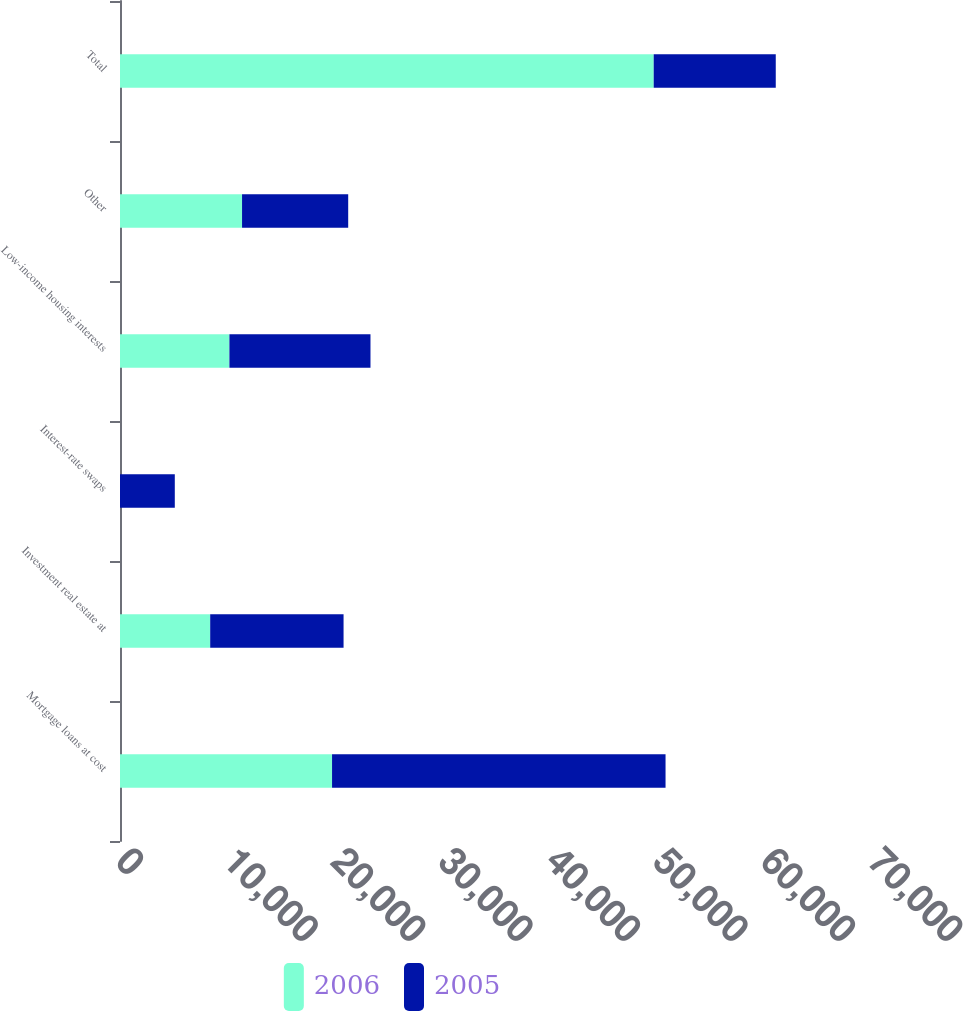Convert chart. <chart><loc_0><loc_0><loc_500><loc_500><stacked_bar_chart><ecel><fcel>Mortgage loans at cost<fcel>Investment real estate at<fcel>Interest-rate swaps<fcel>Low-income housing interests<fcel>Other<fcel>Total<nl><fcel>2006<fcel>19739<fcel>8396<fcel>0<fcel>10185<fcel>11361<fcel>49681<nl><fcel>2005<fcel>31043<fcel>12414<fcel>5101<fcel>13131<fcel>9881<fcel>11361<nl></chart> 